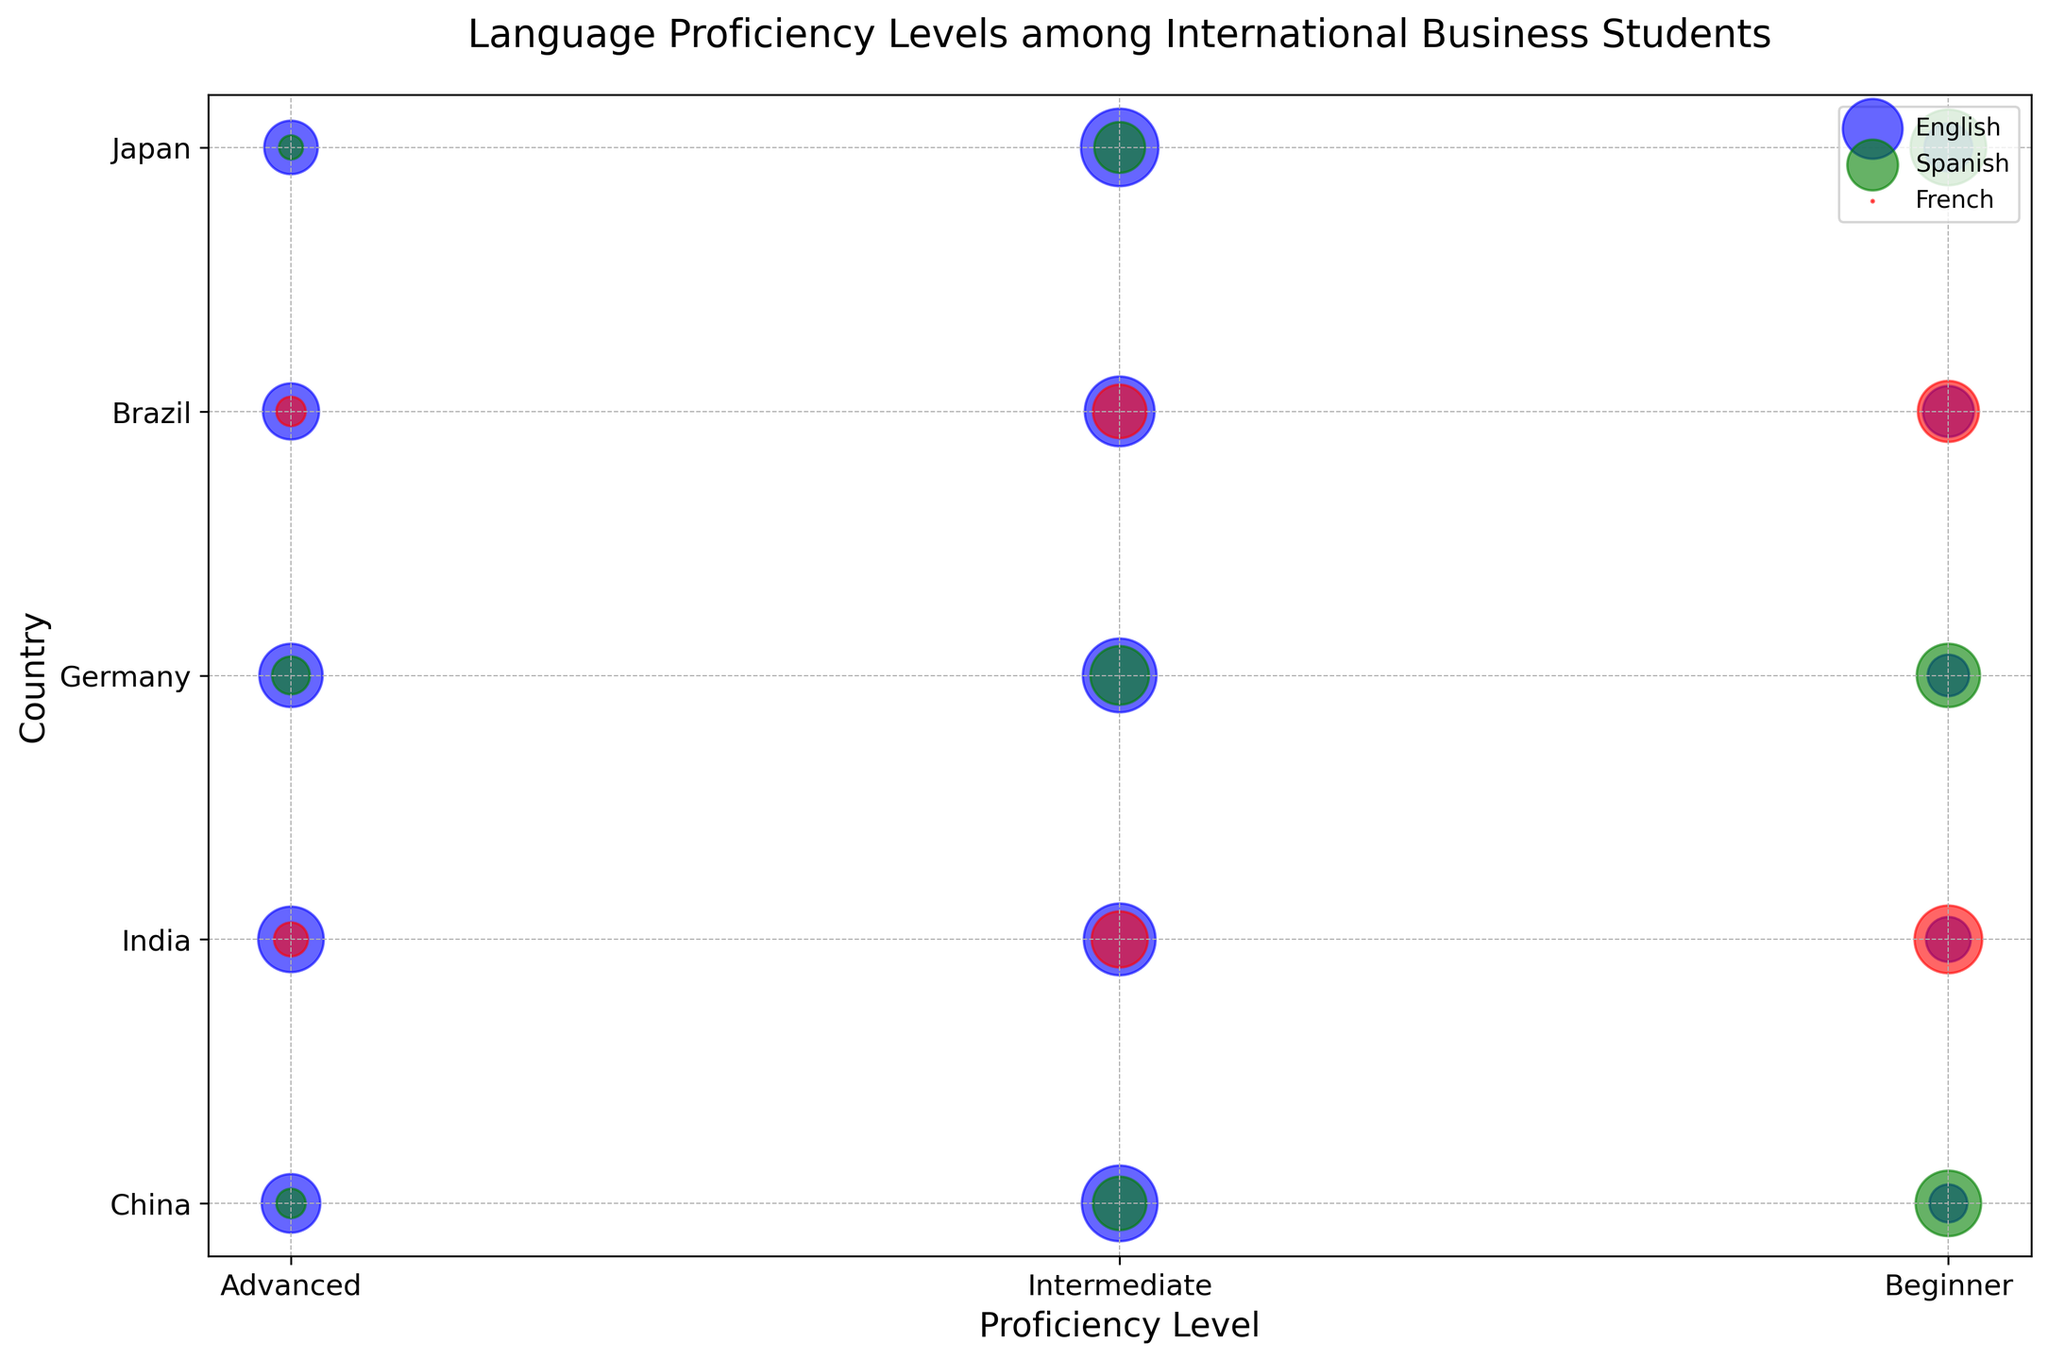Which country has the highest number of advanced English speakers? To find this, look for the largest bubble under "Advanced" proficiency for English across all countries. Compare the size of these bubbles.
Answer: India Which language proficiency level has the smallest number of students in Japan? Observe and compare all the bubble sizes corresponding to Japan across different languages and proficiency levels to identify the smallest one.
Answer: Advanced Spanish What is the total number of students with beginner proficiency in English for China and Brazil? Sum the sizes of bubbles under "Beginner" proficiency for English in China and Brazil. They are 50 (China) and 90 (Brazil), respectively. 50 + 90 = 140
Answer: 140 Is there a noticeable difference in the number of beginner French speakers between Brazil and India? Compare the sizes of bubbles under "Beginner" proficiency for French in Brazil and India. Brazil has 130, India has 160. Check if the sizes significantly differ.
Answer: Yes Which country has a larger number of students with intermediate Spanish proficiency, China or Germany? Compare the sizes of the bubbles under "Intermediate" proficiency for Spanish in China and Germany. China has 100, Germany has 120.
Answer: Germany What’s the ratio of intermediate to advanced English speakers in Germany? Use the sizes of the two bubbles for Intermediate and Advanced English proficiency in Germany. Intermediate has 190 and Advanced has 140. Ratio = 190 / 140 ≈ 1.36
Answer: 1.36 Between Japan and China, which country has a higher overall number of students with beginner language proficiency regardless of language? Add up the sizes of the bubbles for Beginner proficiency in all languages for Japan (80 + 200) and China (50 + 150). Japan = 280, China = 200. Compare these totals.
Answer: Japan How does the number of advanced English speakers in China compare to the number of intermediate French speakers in Brazil? Compare the sizes of the respective bubbles: Advanced English in China has 120, Intermediate French in Brazil has 100.
Answer: Advanced English speakers in China are more What is the combined number of Spanish learners (all proficiency levels) in Germany? Sum the sizes of bubbles for all proficiency levels of Spanish in Germany. 50 (Advanced) + 120 (Intermediate) + 140 (Beginner) = 310
Answer: 310 Which proficiency level has the least number of French learners in India? Compare the sizes of the bubbles for French in India across all proficiency levels. Beginner has 160, Intermediate has 110, and Advanced has 40.
Answer: Advanced 